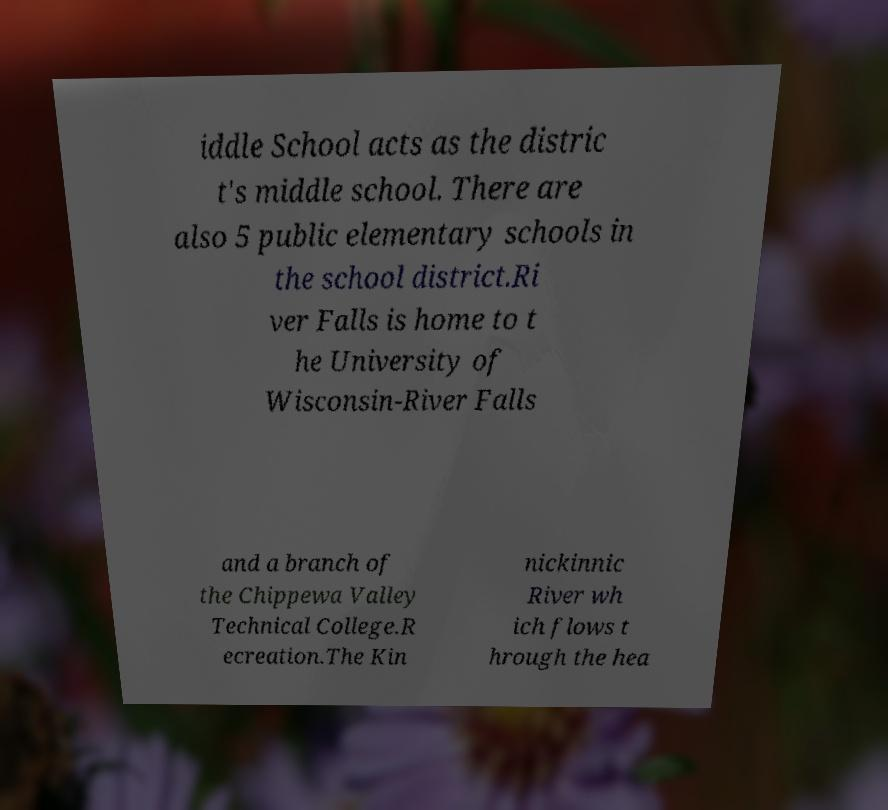Could you extract and type out the text from this image? iddle School acts as the distric t's middle school. There are also 5 public elementary schools in the school district.Ri ver Falls is home to t he University of Wisconsin-River Falls and a branch of the Chippewa Valley Technical College.R ecreation.The Kin nickinnic River wh ich flows t hrough the hea 